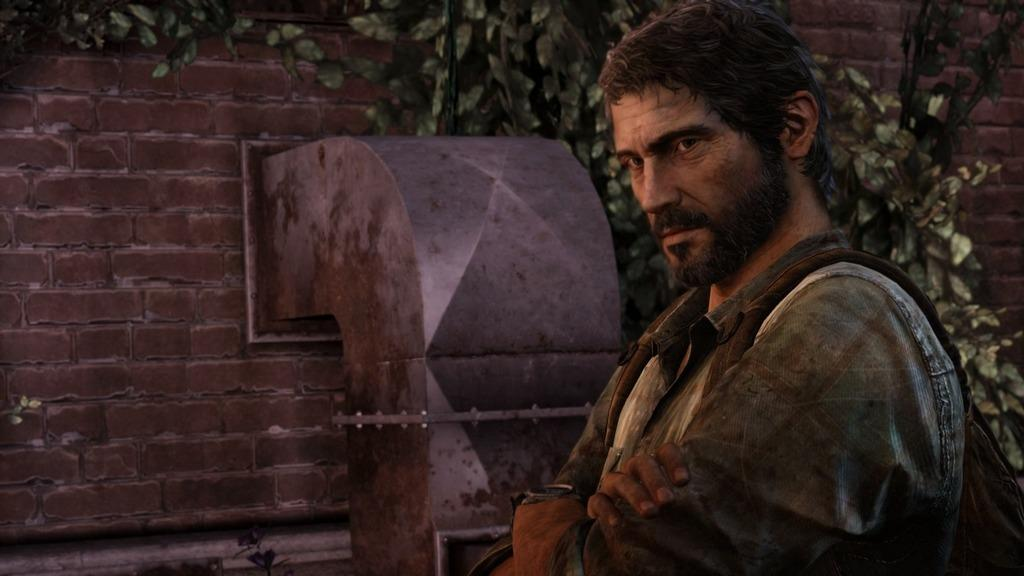Who is present in the image? There is a man in the image. What is behind the man in the image? There is a brick wall behind the man. What is in front of the brick wall in the image? There is a plant in front of the brick wall. What color is the sock that the man is wearing in the image? There is no sock mentioned or visible in the image. 